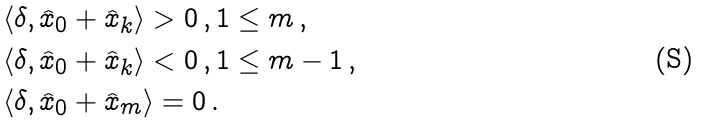Convert formula to latex. <formula><loc_0><loc_0><loc_500><loc_500>& \langle \delta , \widehat { x } _ { 0 } + \widehat { x } _ { k } \rangle > 0 \, , 1 \leq m \, , \\ & \langle \delta , \widehat { x } _ { 0 } + \widehat { x } _ { k } \rangle < 0 \, , 1 \leq m - 1 \, , \\ & \langle \delta , \widehat { x } _ { 0 } + \widehat { x } _ { m } \rangle = 0 \, .</formula> 